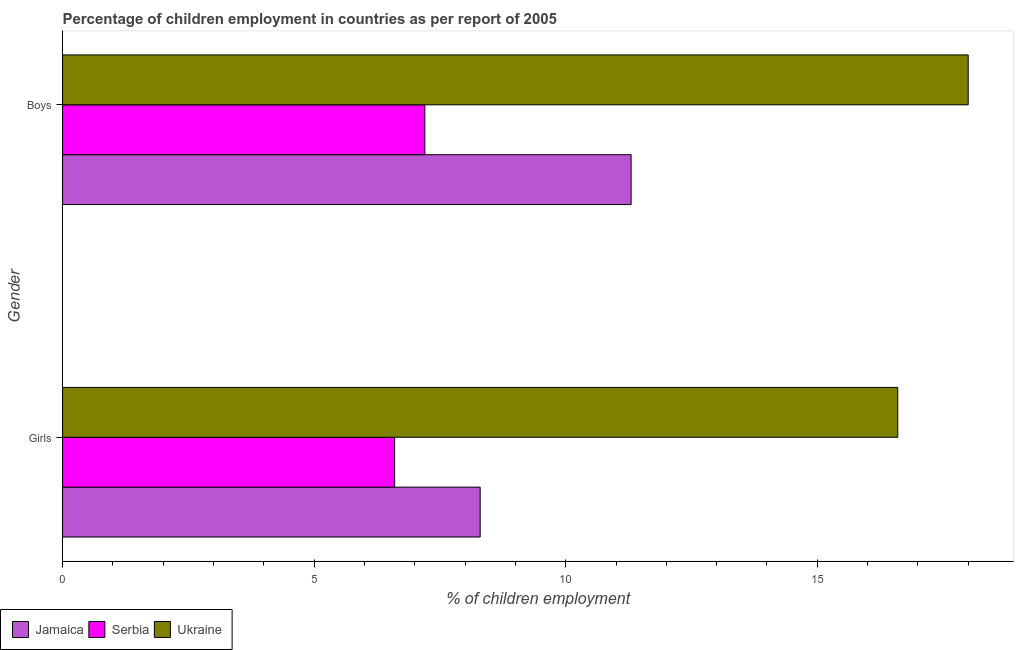How many different coloured bars are there?
Ensure brevity in your answer.  3. Are the number of bars on each tick of the Y-axis equal?
Offer a terse response. Yes. What is the label of the 2nd group of bars from the top?
Offer a very short reply. Girls. In which country was the percentage of employed boys maximum?
Your answer should be compact. Ukraine. In which country was the percentage of employed girls minimum?
Ensure brevity in your answer.  Serbia. What is the total percentage of employed girls in the graph?
Make the answer very short. 31.5. What is the difference between the percentage of employed boys in Jamaica and that in Serbia?
Your response must be concise. 4.1. What is the difference between the percentage of employed girls in Jamaica and the percentage of employed boys in Ukraine?
Make the answer very short. -9.7. What is the average percentage of employed boys per country?
Your answer should be very brief. 12.17. What is the difference between the percentage of employed girls and percentage of employed boys in Ukraine?
Offer a very short reply. -1.4. In how many countries, is the percentage of employed boys greater than 11 %?
Offer a terse response. 2. Is the percentage of employed boys in Jamaica less than that in Ukraine?
Offer a terse response. Yes. In how many countries, is the percentage of employed boys greater than the average percentage of employed boys taken over all countries?
Keep it short and to the point. 1. What does the 2nd bar from the top in Boys represents?
Make the answer very short. Serbia. What does the 3rd bar from the bottom in Girls represents?
Your response must be concise. Ukraine. How many bars are there?
Offer a very short reply. 6. Are all the bars in the graph horizontal?
Keep it short and to the point. Yes. Are the values on the major ticks of X-axis written in scientific E-notation?
Offer a very short reply. No. Does the graph contain any zero values?
Your response must be concise. No. Does the graph contain grids?
Offer a terse response. No. How many legend labels are there?
Make the answer very short. 3. How are the legend labels stacked?
Give a very brief answer. Horizontal. What is the title of the graph?
Provide a succinct answer. Percentage of children employment in countries as per report of 2005. Does "Gambia, The" appear as one of the legend labels in the graph?
Your response must be concise. No. What is the label or title of the X-axis?
Your answer should be very brief. % of children employment. What is the label or title of the Y-axis?
Your response must be concise. Gender. What is the % of children employment of Ukraine in Girls?
Give a very brief answer. 16.6. What is the % of children employment of Serbia in Boys?
Make the answer very short. 7.2. What is the total % of children employment in Jamaica in the graph?
Provide a succinct answer. 19.6. What is the total % of children employment in Ukraine in the graph?
Your answer should be compact. 34.6. What is the difference between the % of children employment in Jamaica in Girls and that in Boys?
Provide a succinct answer. -3. What is the difference between the % of children employment of Serbia in Girls and that in Boys?
Make the answer very short. -0.6. What is the difference between the % of children employment in Jamaica in Girls and the % of children employment in Ukraine in Boys?
Offer a terse response. -9.7. What is the average % of children employment of Jamaica per Gender?
Your answer should be very brief. 9.8. What is the difference between the % of children employment of Jamaica and % of children employment of Serbia in Girls?
Offer a terse response. 1.7. What is the difference between the % of children employment of Jamaica and % of children employment of Ukraine in Girls?
Make the answer very short. -8.3. What is the difference between the % of children employment in Jamaica and % of children employment in Serbia in Boys?
Make the answer very short. 4.1. What is the ratio of the % of children employment in Jamaica in Girls to that in Boys?
Your answer should be very brief. 0.73. What is the ratio of the % of children employment of Ukraine in Girls to that in Boys?
Give a very brief answer. 0.92. What is the difference between the highest and the second highest % of children employment of Jamaica?
Keep it short and to the point. 3. What is the difference between the highest and the second highest % of children employment of Ukraine?
Offer a terse response. 1.4. What is the difference between the highest and the lowest % of children employment in Jamaica?
Your answer should be compact. 3. What is the difference between the highest and the lowest % of children employment of Serbia?
Give a very brief answer. 0.6. 